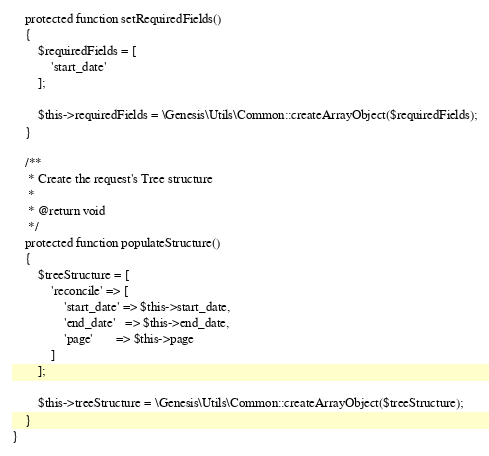<code> <loc_0><loc_0><loc_500><loc_500><_PHP_>    protected function setRequiredFields()
    {
        $requiredFields = [
            'start_date'
        ];

        $this->requiredFields = \Genesis\Utils\Common::createArrayObject($requiredFields);
    }

    /**
     * Create the request's Tree structure
     *
     * @return void
     */
    protected function populateStructure()
    {
        $treeStructure = [
            'reconcile' => [
                'start_date' => $this->start_date,
                'end_date'   => $this->end_date,
                'page'       => $this->page
            ]
        ];

        $this->treeStructure = \Genesis\Utils\Common::createArrayObject($treeStructure);
    }
}
</code> 